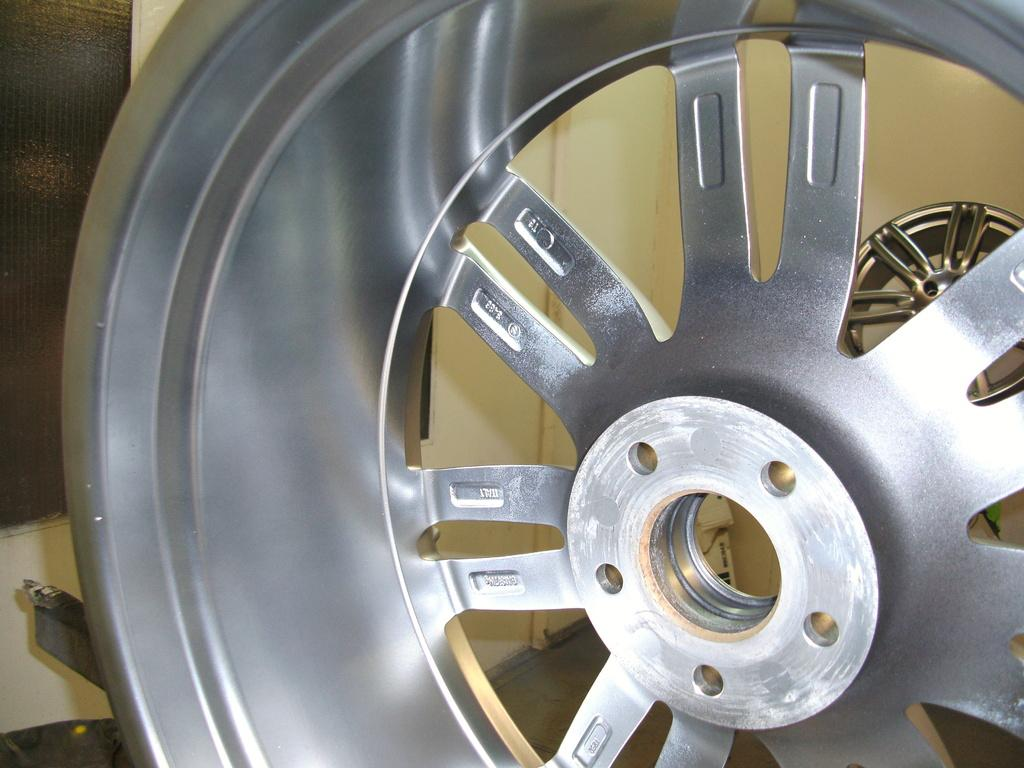What object is the main focus of the image? There is a hubcap in the image. What can be seen in the background of the image? There is a wall, a window, and a door in the background of the image. Are there any other hubcaps visible in the image? Yes, there is another hubcap in the background of the image. What type of minister is standing near the hydrant in the image? There is no minister or hydrant present in the image; it only features a hubcap and background elements. 